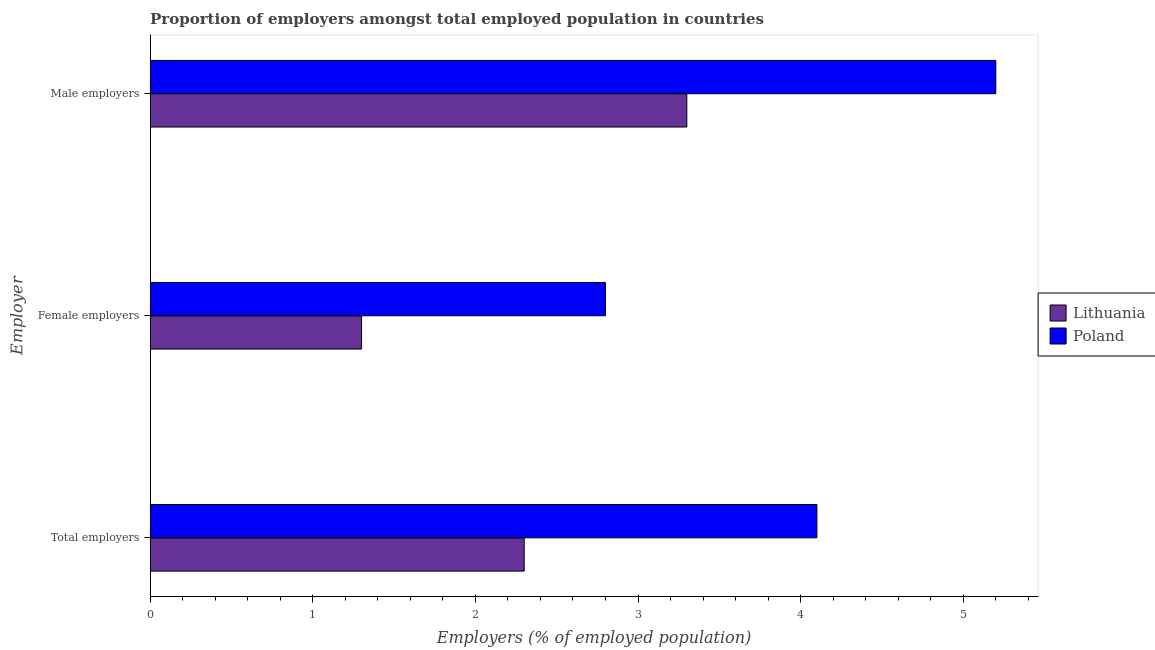How many groups of bars are there?
Ensure brevity in your answer.  3. Are the number of bars per tick equal to the number of legend labels?
Ensure brevity in your answer.  Yes. How many bars are there on the 3rd tick from the top?
Offer a terse response. 2. How many bars are there on the 2nd tick from the bottom?
Your answer should be compact. 2. What is the label of the 2nd group of bars from the top?
Provide a succinct answer. Female employers. What is the percentage of male employers in Poland?
Your answer should be compact. 5.2. Across all countries, what is the maximum percentage of female employers?
Ensure brevity in your answer.  2.8. Across all countries, what is the minimum percentage of male employers?
Your answer should be very brief. 3.3. In which country was the percentage of male employers maximum?
Provide a succinct answer. Poland. In which country was the percentage of male employers minimum?
Provide a succinct answer. Lithuania. What is the total percentage of total employers in the graph?
Your answer should be very brief. 6.4. What is the difference between the percentage of total employers in Lithuania and that in Poland?
Provide a succinct answer. -1.8. What is the average percentage of total employers per country?
Your answer should be compact. 3.2. What is the difference between the percentage of male employers and percentage of female employers in Poland?
Your answer should be compact. 2.4. What is the ratio of the percentage of male employers in Poland to that in Lithuania?
Offer a very short reply. 1.58. Is the difference between the percentage of male employers in Poland and Lithuania greater than the difference between the percentage of total employers in Poland and Lithuania?
Your answer should be compact. Yes. What is the difference between the highest and the second highest percentage of female employers?
Make the answer very short. 1.5. What is the difference between the highest and the lowest percentage of female employers?
Make the answer very short. 1.5. Is the sum of the percentage of total employers in Lithuania and Poland greater than the maximum percentage of female employers across all countries?
Give a very brief answer. Yes. What does the 2nd bar from the top in Male employers represents?
Offer a terse response. Lithuania. What does the 2nd bar from the bottom in Male employers represents?
Your answer should be compact. Poland. How many bars are there?
Your answer should be compact. 6. What is the difference between two consecutive major ticks on the X-axis?
Make the answer very short. 1. Are the values on the major ticks of X-axis written in scientific E-notation?
Provide a short and direct response. No. Does the graph contain any zero values?
Provide a succinct answer. No. Where does the legend appear in the graph?
Keep it short and to the point. Center right. How are the legend labels stacked?
Provide a short and direct response. Vertical. What is the title of the graph?
Give a very brief answer. Proportion of employers amongst total employed population in countries. Does "Benin" appear as one of the legend labels in the graph?
Your response must be concise. No. What is the label or title of the X-axis?
Offer a very short reply. Employers (% of employed population). What is the label or title of the Y-axis?
Your answer should be compact. Employer. What is the Employers (% of employed population) in Lithuania in Total employers?
Offer a very short reply. 2.3. What is the Employers (% of employed population) in Poland in Total employers?
Ensure brevity in your answer.  4.1. What is the Employers (% of employed population) of Lithuania in Female employers?
Your response must be concise. 1.3. What is the Employers (% of employed population) in Poland in Female employers?
Give a very brief answer. 2.8. What is the Employers (% of employed population) in Lithuania in Male employers?
Your answer should be very brief. 3.3. What is the Employers (% of employed population) of Poland in Male employers?
Keep it short and to the point. 5.2. Across all Employer, what is the maximum Employers (% of employed population) of Lithuania?
Your response must be concise. 3.3. Across all Employer, what is the maximum Employers (% of employed population) of Poland?
Offer a very short reply. 5.2. Across all Employer, what is the minimum Employers (% of employed population) of Lithuania?
Provide a short and direct response. 1.3. Across all Employer, what is the minimum Employers (% of employed population) of Poland?
Your answer should be very brief. 2.8. What is the total Employers (% of employed population) in Poland in the graph?
Make the answer very short. 12.1. What is the difference between the Employers (% of employed population) of Lithuania in Total employers and that in Female employers?
Ensure brevity in your answer.  1. What is the difference between the Employers (% of employed population) of Poland in Total employers and that in Female employers?
Your answer should be very brief. 1.3. What is the difference between the Employers (% of employed population) in Lithuania in Total employers and that in Male employers?
Give a very brief answer. -1. What is the difference between the Employers (% of employed population) of Poland in Total employers and that in Male employers?
Make the answer very short. -1.1. What is the difference between the Employers (% of employed population) of Lithuania in Female employers and that in Male employers?
Ensure brevity in your answer.  -2. What is the difference between the Employers (% of employed population) in Lithuania in Total employers and the Employers (% of employed population) in Poland in Female employers?
Your answer should be very brief. -0.5. What is the difference between the Employers (% of employed population) in Lithuania in Total employers and the Employers (% of employed population) in Poland in Male employers?
Provide a short and direct response. -2.9. What is the difference between the Employers (% of employed population) in Lithuania in Female employers and the Employers (% of employed population) in Poland in Male employers?
Your answer should be very brief. -3.9. What is the average Employers (% of employed population) of Poland per Employer?
Your response must be concise. 4.03. What is the ratio of the Employers (% of employed population) of Lithuania in Total employers to that in Female employers?
Ensure brevity in your answer.  1.77. What is the ratio of the Employers (% of employed population) of Poland in Total employers to that in Female employers?
Ensure brevity in your answer.  1.46. What is the ratio of the Employers (% of employed population) in Lithuania in Total employers to that in Male employers?
Your answer should be compact. 0.7. What is the ratio of the Employers (% of employed population) of Poland in Total employers to that in Male employers?
Offer a very short reply. 0.79. What is the ratio of the Employers (% of employed population) in Lithuania in Female employers to that in Male employers?
Provide a succinct answer. 0.39. What is the ratio of the Employers (% of employed population) in Poland in Female employers to that in Male employers?
Offer a very short reply. 0.54. What is the difference between the highest and the second highest Employers (% of employed population) in Poland?
Make the answer very short. 1.1. What is the difference between the highest and the lowest Employers (% of employed population) of Lithuania?
Make the answer very short. 2. What is the difference between the highest and the lowest Employers (% of employed population) in Poland?
Offer a very short reply. 2.4. 